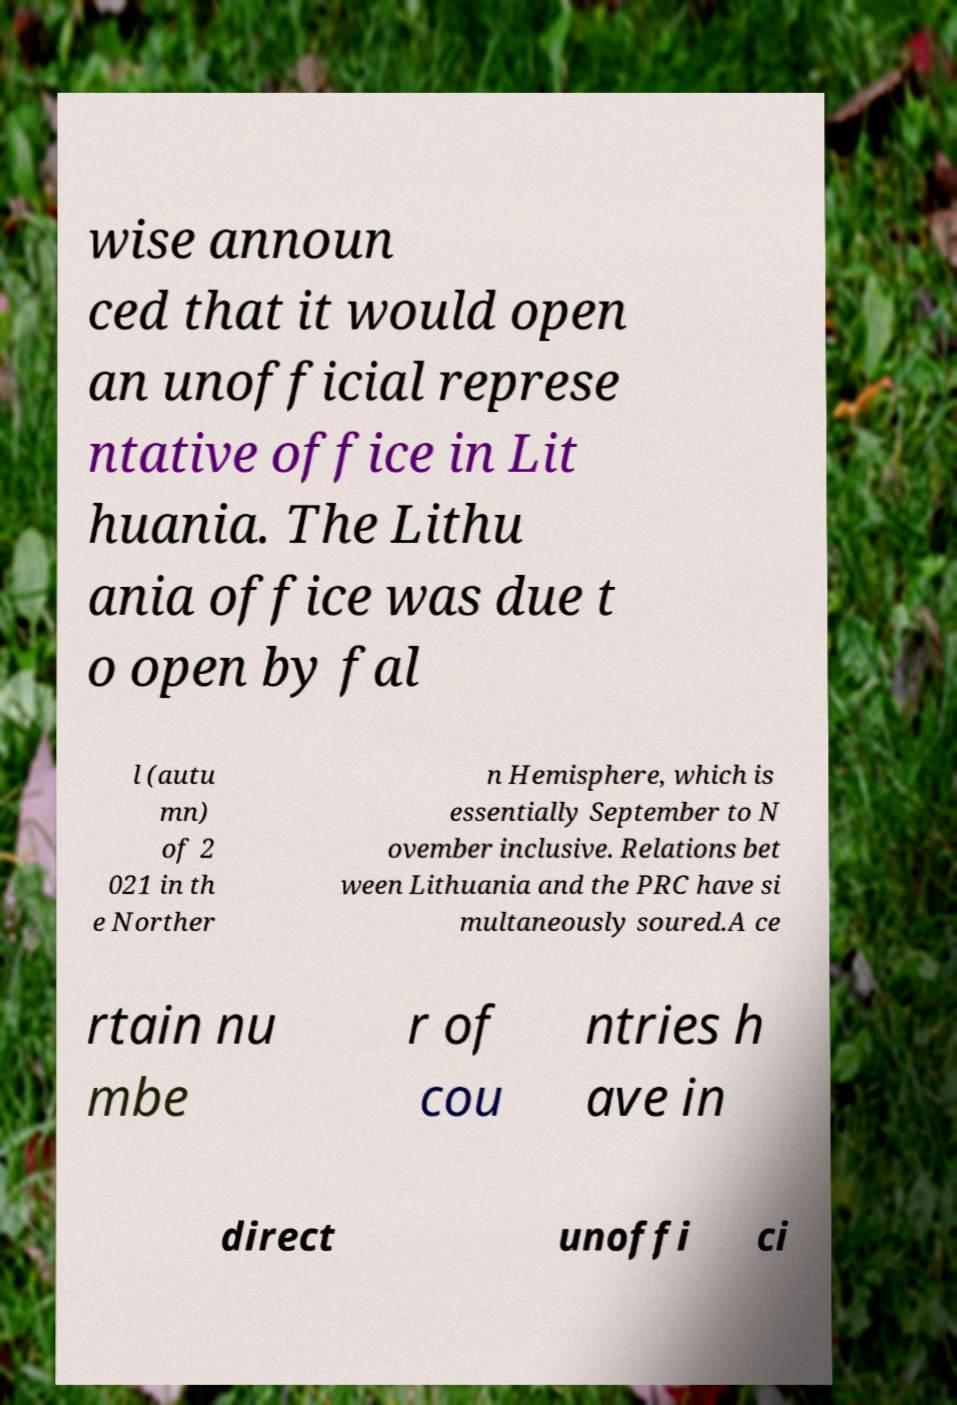For documentation purposes, I need the text within this image transcribed. Could you provide that? wise announ ced that it would open an unofficial represe ntative office in Lit huania. The Lithu ania office was due t o open by fal l (autu mn) of 2 021 in th e Norther n Hemisphere, which is essentially September to N ovember inclusive. Relations bet ween Lithuania and the PRC have si multaneously soured.A ce rtain nu mbe r of cou ntries h ave in direct unoffi ci 